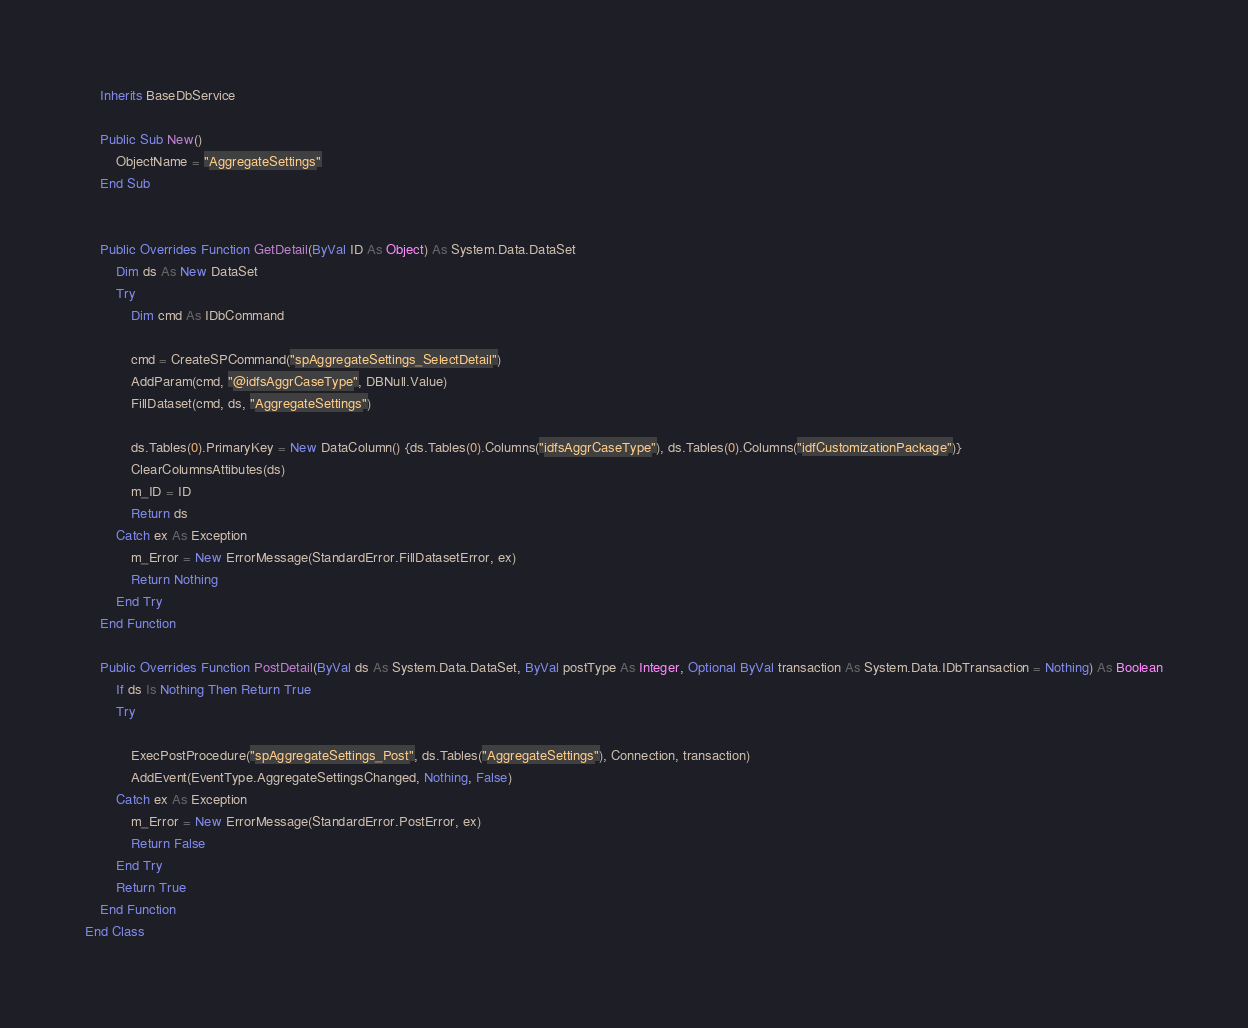Convert code to text. <code><loc_0><loc_0><loc_500><loc_500><_VisualBasic_>    Inherits BaseDbService

    Public Sub New()
        ObjectName = "AggregateSettings"
    End Sub


    Public Overrides Function GetDetail(ByVal ID As Object) As System.Data.DataSet
        Dim ds As New DataSet
        Try
            Dim cmd As IDbCommand

            cmd = CreateSPCommand("spAggregateSettings_SelectDetail")
            AddParam(cmd, "@idfsAggrCaseType", DBNull.Value)
            FillDataset(cmd, ds, "AggregateSettings")

            ds.Tables(0).PrimaryKey = New DataColumn() {ds.Tables(0).Columns("idfsAggrCaseType"), ds.Tables(0).Columns("idfCustomizationPackage")}
            ClearColumnsAttibutes(ds)
            m_ID = ID
            Return ds
        Catch ex As Exception
            m_Error = New ErrorMessage(StandardError.FillDatasetError, ex)
            Return Nothing
        End Try
    End Function

    Public Overrides Function PostDetail(ByVal ds As System.Data.DataSet, ByVal postType As Integer, Optional ByVal transaction As System.Data.IDbTransaction = Nothing) As Boolean
        If ds Is Nothing Then Return True
        Try

            ExecPostProcedure("spAggregateSettings_Post", ds.Tables("AggregateSettings"), Connection, transaction)
            AddEvent(EventType.AggregateSettingsChanged, Nothing, False)
        Catch ex As Exception
            m_Error = New ErrorMessage(StandardError.PostError, ex)
            Return False
        End Try
        Return True
    End Function
End Class
</code> 